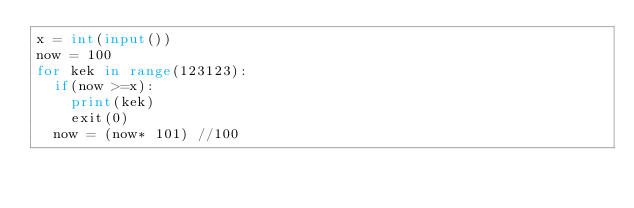<code> <loc_0><loc_0><loc_500><loc_500><_Python_>x = int(input())
now = 100
for kek in range(123123):
	if(now >=x):
		print(kek)
		exit(0)
	now = (now* 101) //100</code> 